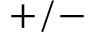<formula> <loc_0><loc_0><loc_500><loc_500>+ / -</formula> 